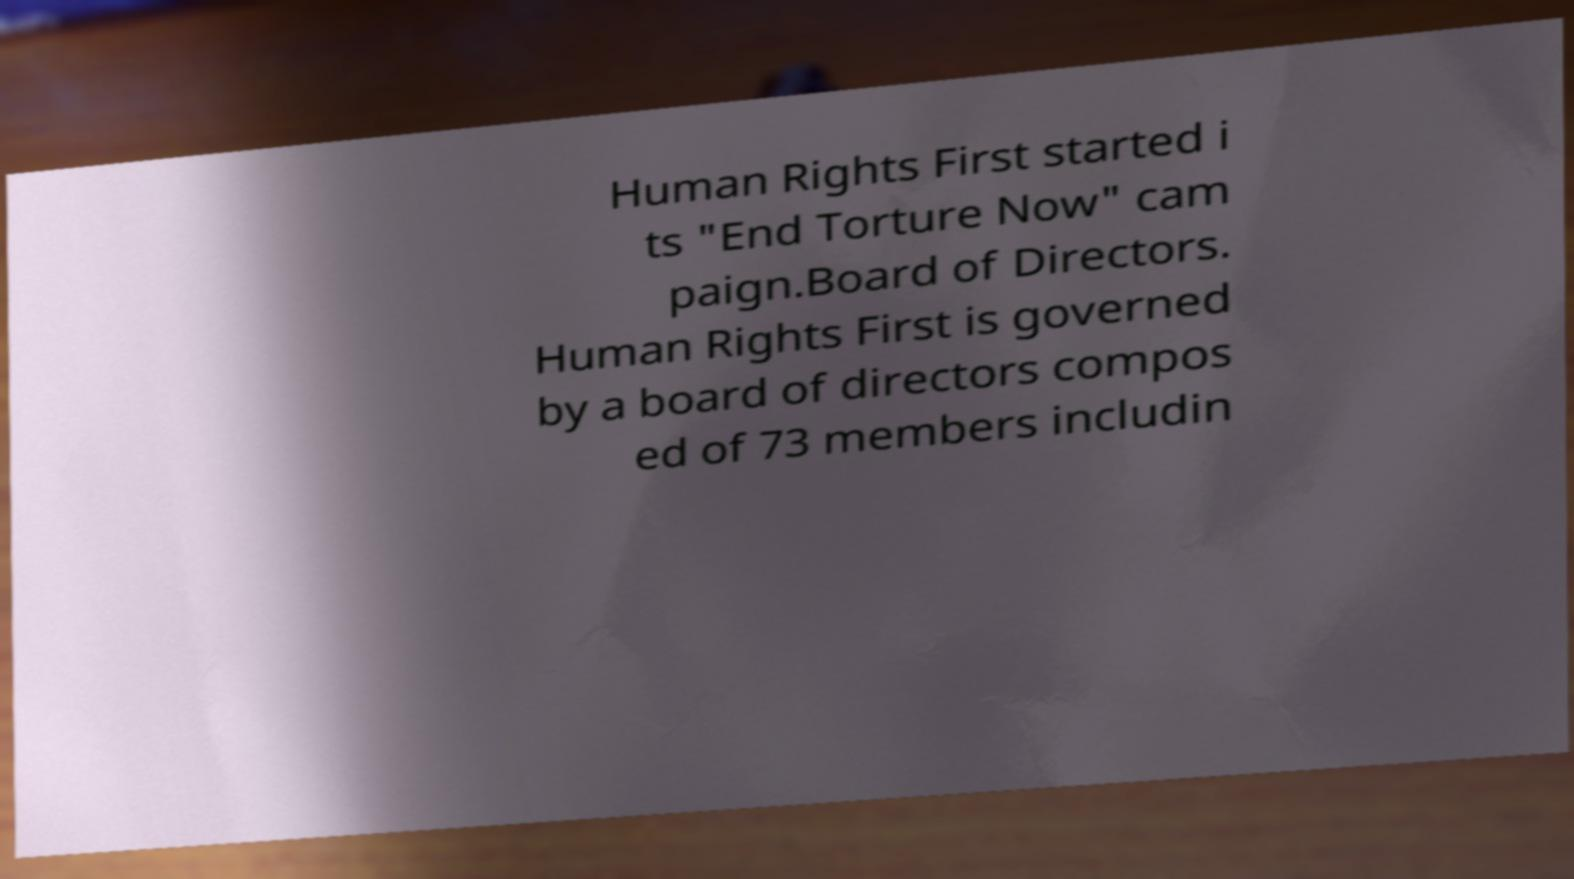Please identify and transcribe the text found in this image. Human Rights First started i ts "End Torture Now" cam paign.Board of Directors. Human Rights First is governed by a board of directors compos ed of 73 members includin 